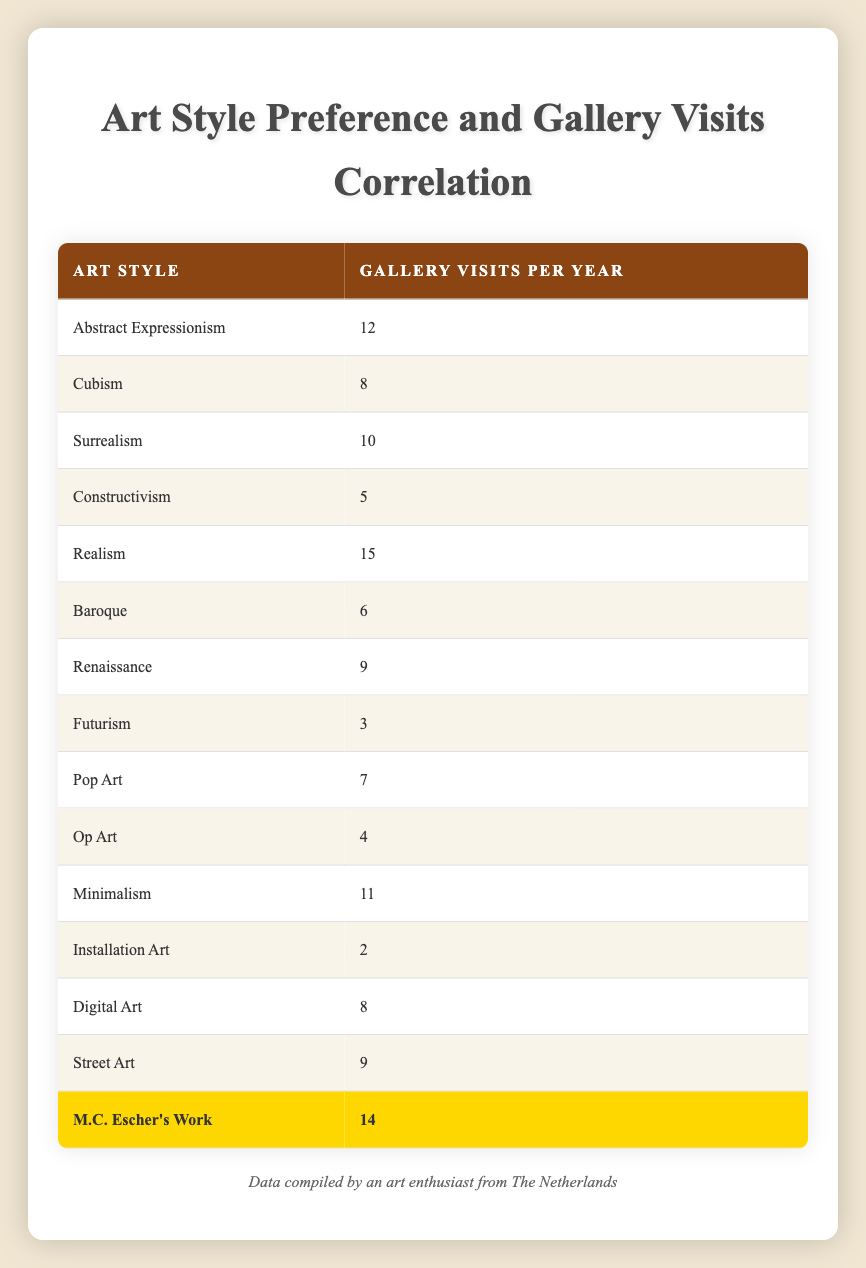What is the frequency of gallery visits per year for M.C. Escher's work? The table lists M.C. Escher's work in the last row. Looking at that row, it shows that the frequency of gallery visits per year is 14.
Answer: 14 Which art style has the highest frequency of gallery visits per year? By observing the table, we see that "Realism" has 15 visits per year, which is the highest compared to other styles.
Answer: Realism What is the average frequency of gallery visits for the styles listed in the table? To find the average, we sum up all the frequencies: 12 + 8 + 10 + 5 + 15 + 6 + 9 + 3 + 7 + 4 + 11 + 2 + 8 + 9 + 14 =  12.33. Since there are 15 styles, we divide the total by 15: 180/15 = 12.
Answer: 12 Is Surrealism associated with more or fewer gallery visits than Minimalism? Surrealism has 10 visits, while Minimalism has 11 visits. Since 10 is less than 11, Surrealism is associated with fewer gallery visits.
Answer: Fewer Which art styles have a frequency of gallery visits below 5? Looking at the table, we see that "Futurism" has 3, "Op Art" has 4, and "Installation Art" has 2. Therefore, these three styles have frequencies below 5.
Answer: Futurism, Op Art, Installation Art How many art styles have a frequency of gallery visits that is equal to or greater than 10? The following styles have 10 or more visits: Abstract Expressionism (12), Surrealism (10), Realism (15), Minimalism (11), M.C. Escher's Work (14). Thus, there are five styles meeting this criterion.
Answer: 5 What is the difference in frequency of visits between Realism and Constructivism? Realism has 15 visits, and Constructivism has 5. The difference is calculated as 15 - 5 = 10.
Answer: 10 Are there any art styles that have the same frequency of gallery visits? By checking the table, we find that Cubism and Digital Art both have 8 visits. Since these are equal, the answer is yes, they share the same frequency.
Answer: Yes How many art styles have a frequency of gallery visits greater than 8? Examining the table, we find that the following styles have more than 8 visits: Abstract Expressionism (12), Surrealism (10), Realism (15), Minimalism (11), and M.C. Escher's Work (14). This totals to five styles.
Answer: 5 